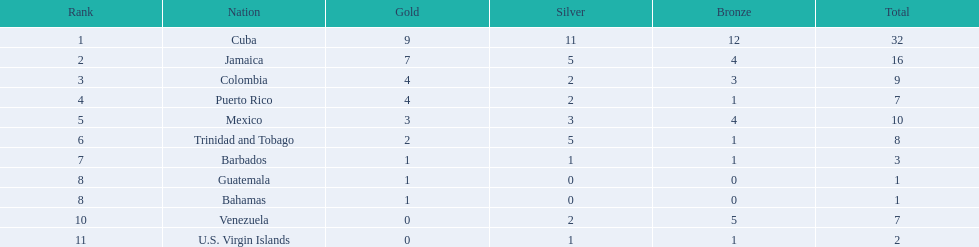Which countries competed in the 1966 central american and caribbean games? Cuba, Jamaica, Colombia, Puerto Rico, Mexico, Trinidad and Tobago, Barbados, Guatemala, Bahamas, Venezuela, U.S. Virgin Islands. Which countries won at least six silver medals at these games? Cuba. 